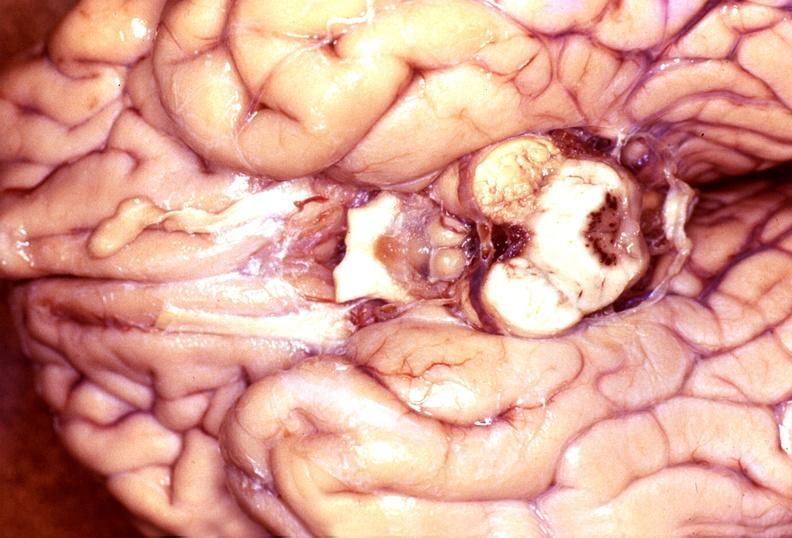s nervous present?
Answer the question using a single word or phrase. Yes 